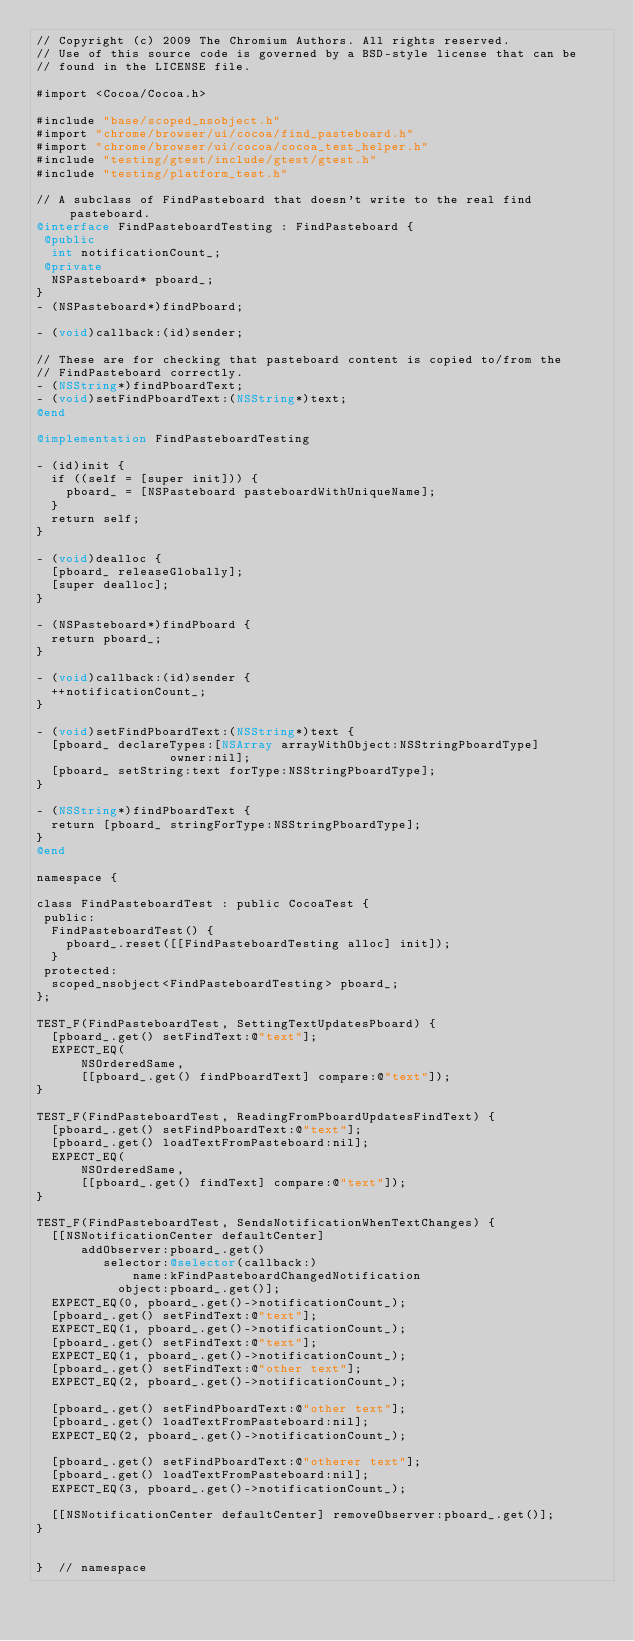<code> <loc_0><loc_0><loc_500><loc_500><_ObjectiveC_>// Copyright (c) 2009 The Chromium Authors. All rights reserved.
// Use of this source code is governed by a BSD-style license that can be
// found in the LICENSE file.

#import <Cocoa/Cocoa.h>

#include "base/scoped_nsobject.h"
#import "chrome/browser/ui/cocoa/find_pasteboard.h"
#import "chrome/browser/ui/cocoa/cocoa_test_helper.h"
#include "testing/gtest/include/gtest/gtest.h"
#include "testing/platform_test.h"

// A subclass of FindPasteboard that doesn't write to the real find pasteboard.
@interface FindPasteboardTesting : FindPasteboard {
 @public
  int notificationCount_;
 @private
  NSPasteboard* pboard_;
}
- (NSPasteboard*)findPboard;

- (void)callback:(id)sender;

// These are for checking that pasteboard content is copied to/from the
// FindPasteboard correctly.
- (NSString*)findPboardText;
- (void)setFindPboardText:(NSString*)text;
@end

@implementation FindPasteboardTesting

- (id)init {
  if ((self = [super init])) {
    pboard_ = [NSPasteboard pasteboardWithUniqueName];
  }
  return self;
}

- (void)dealloc {
  [pboard_ releaseGlobally];
  [super dealloc];
}

- (NSPasteboard*)findPboard {
  return pboard_;
}

- (void)callback:(id)sender {
  ++notificationCount_;
}

- (void)setFindPboardText:(NSString*)text {
  [pboard_ declareTypes:[NSArray arrayWithObject:NSStringPboardType]
                  owner:nil];
  [pboard_ setString:text forType:NSStringPboardType];
}

- (NSString*)findPboardText {
  return [pboard_ stringForType:NSStringPboardType];
}
@end

namespace {

class FindPasteboardTest : public CocoaTest {
 public:
  FindPasteboardTest() {
    pboard_.reset([[FindPasteboardTesting alloc] init]);
  }
 protected:
  scoped_nsobject<FindPasteboardTesting> pboard_;
};

TEST_F(FindPasteboardTest, SettingTextUpdatesPboard) {
  [pboard_.get() setFindText:@"text"];
  EXPECT_EQ(
      NSOrderedSame,
      [[pboard_.get() findPboardText] compare:@"text"]);
}

TEST_F(FindPasteboardTest, ReadingFromPboardUpdatesFindText) {
  [pboard_.get() setFindPboardText:@"text"];
  [pboard_.get() loadTextFromPasteboard:nil];
  EXPECT_EQ(
      NSOrderedSame,
      [[pboard_.get() findText] compare:@"text"]);
}

TEST_F(FindPasteboardTest, SendsNotificationWhenTextChanges) {
  [[NSNotificationCenter defaultCenter]
      addObserver:pboard_.get()
         selector:@selector(callback:)
             name:kFindPasteboardChangedNotification
           object:pboard_.get()];
  EXPECT_EQ(0, pboard_.get()->notificationCount_);
  [pboard_.get() setFindText:@"text"];
  EXPECT_EQ(1, pboard_.get()->notificationCount_);
  [pboard_.get() setFindText:@"text"];
  EXPECT_EQ(1, pboard_.get()->notificationCount_);
  [pboard_.get() setFindText:@"other text"];
  EXPECT_EQ(2, pboard_.get()->notificationCount_);

  [pboard_.get() setFindPboardText:@"other text"];
  [pboard_.get() loadTextFromPasteboard:nil];
  EXPECT_EQ(2, pboard_.get()->notificationCount_);

  [pboard_.get() setFindPboardText:@"otherer text"];
  [pboard_.get() loadTextFromPasteboard:nil];
  EXPECT_EQ(3, pboard_.get()->notificationCount_);

  [[NSNotificationCenter defaultCenter] removeObserver:pboard_.get()];
}


}  // namespace
</code> 